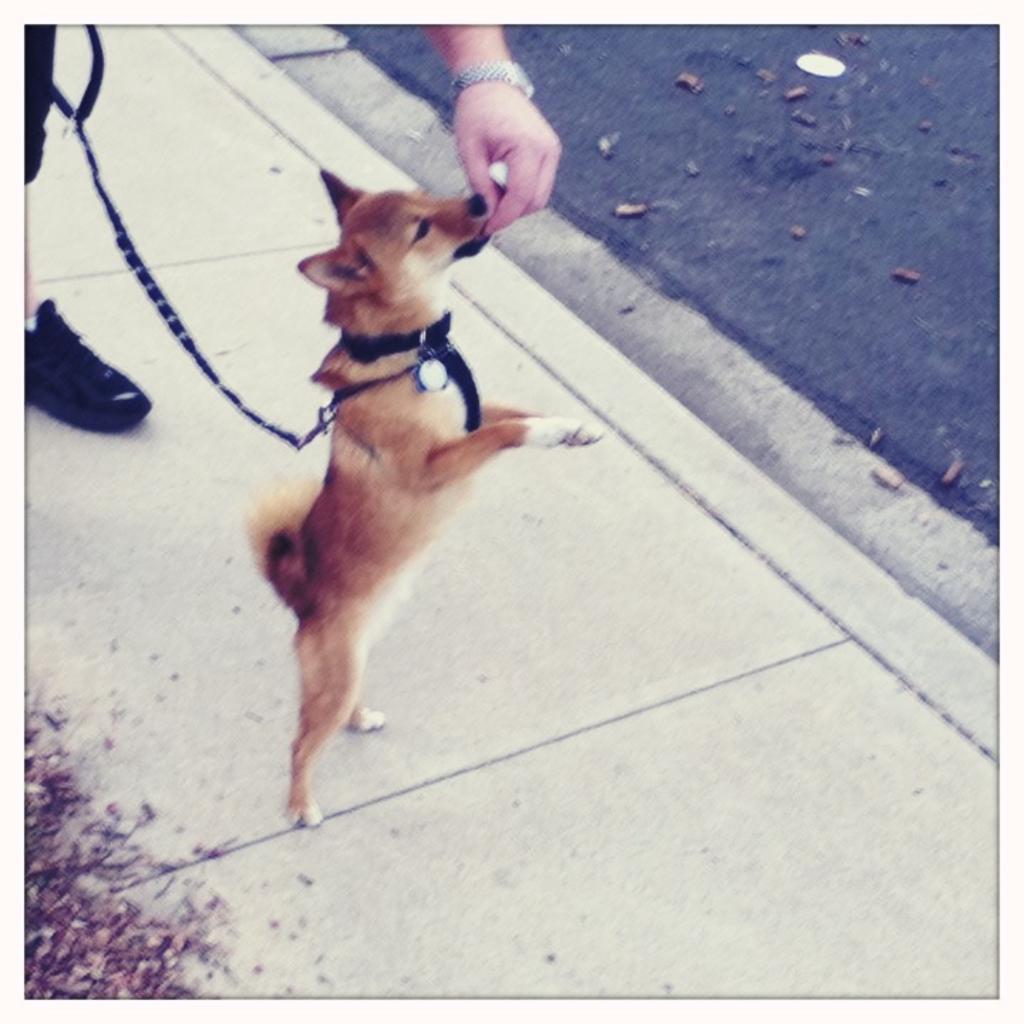How would you summarize this image in a sentence or two? In this image we can see a dog on the pavement. We can see collar around the neck of the dog. We can see a human leg and a hand at the top of the image. It seems like road in the right top of the image. There is a dry grass in the left bottom of the image. 